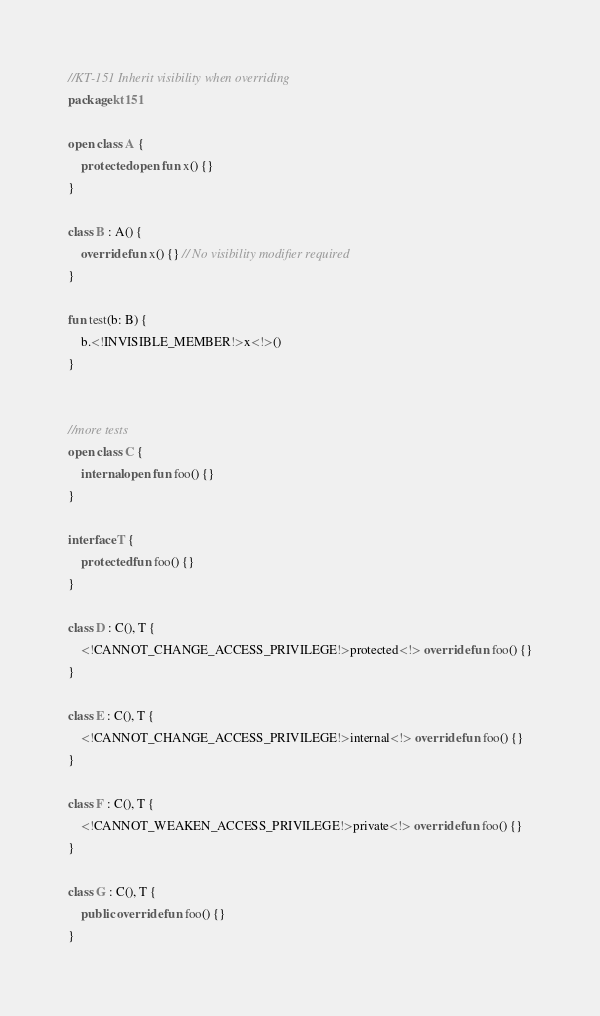Convert code to text. <code><loc_0><loc_0><loc_500><loc_500><_Kotlin_>//KT-151 Inherit visibility when overriding
package kt151

open class A {
    protected open fun x() {}
}

class B : A() {
    override fun x() {} // No visibility modifier required
}

fun test(b: B) {
    b.<!INVISIBLE_MEMBER!>x<!>()
}


//more tests
open class C {
    internal open fun foo() {}
}

interface T {
    protected fun foo() {}
}

class D : C(), T {
    <!CANNOT_CHANGE_ACCESS_PRIVILEGE!>protected<!> override fun foo() {}
}

class E : C(), T {
    <!CANNOT_CHANGE_ACCESS_PRIVILEGE!>internal<!> override fun foo() {}
}

class F : C(), T {
    <!CANNOT_WEAKEN_ACCESS_PRIVILEGE!>private<!> override fun foo() {}
}

class G : C(), T {
    public override fun foo() {}
}</code> 